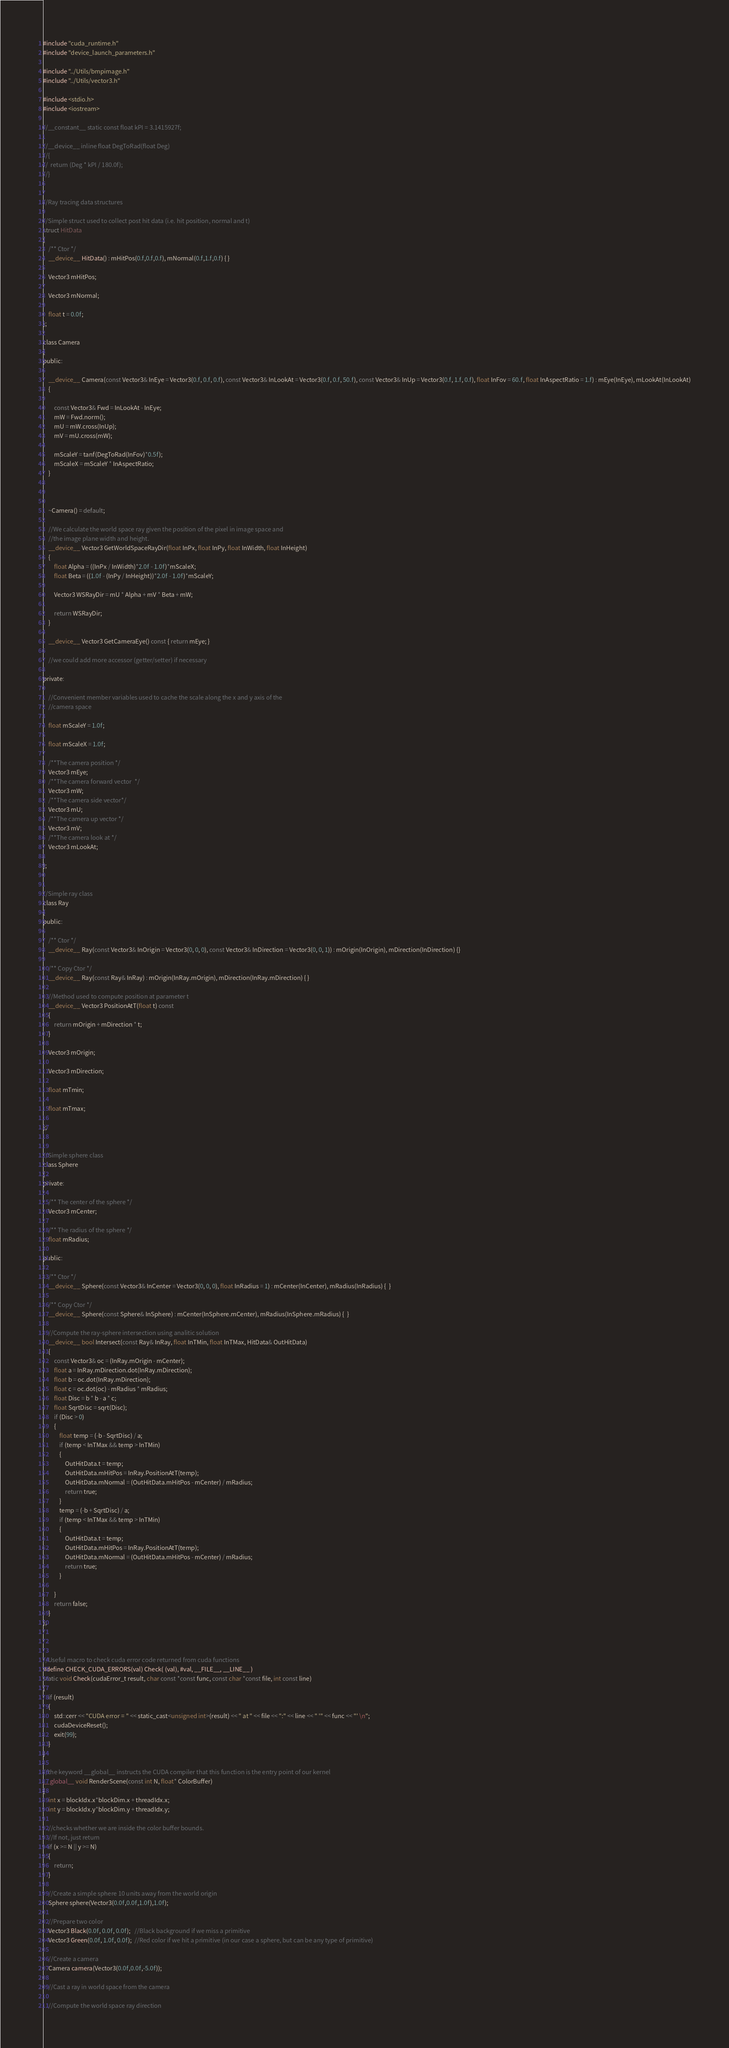<code> <loc_0><loc_0><loc_500><loc_500><_Cuda_>
#include "cuda_runtime.h"
#include "device_launch_parameters.h"

#include "../Utils/bmpimage.h"
#include "../Utils/vector3.h"

#include <stdio.h>
#include <iostream>

//__constant__ static const float kPI = 3.1415927f;

//__device__ inline float DegToRad(float Deg)
//{
//	return (Deg * kPI / 180.0f);
//}


//Ray tracing data structures

//Simple struct used to collect post hit data (i.e. hit position, normal and t)
struct HitData
{
	/** Ctor */
	__device__ HitData() : mHitPos(0.f,0.f,0.f), mNormal(0.f,1.f,0.f) { }
	
	Vector3 mHitPos;
	
	Vector3 mNormal;
	
	float t = 0.0f;
};

class Camera
{
public:

	__device__ Camera(const Vector3& InEye = Vector3(0.f, 0.f, 0.f), const Vector3& InLookAt = Vector3(0.f, 0.f, 50.f), const Vector3& InUp = Vector3(0.f, 1.f, 0.f), float InFov = 60.f, float InAspectRatio = 1.f) : mEye(InEye), mLookAt(InLookAt)
	{

		const Vector3& Fwd = InLookAt - InEye;
		mW = Fwd.norm();
		mU = mW.cross(InUp);
		mV = mU.cross(mW);

		mScaleY = tanf(DegToRad(InFov)*0.5f);
		mScaleX = mScaleY * InAspectRatio;
	}

	

	~Camera() = default;

	//We calculate the world space ray given the position of the pixel in image space and 
	//the image plane width and height.
	__device__ Vector3 GetWorldSpaceRayDir(float InPx, float InPy, float InWidth, float InHeight)
	{
		float Alpha = ((InPx / InWidth)*2.0f - 1.0f)*mScaleX;
		float Beta = ((1.0f - (InPy / InHeight))*2.0f - 1.0f)*mScaleY;

		Vector3 WSRayDir = mU * Alpha + mV * Beta + mW;

		return WSRayDir;
	}

	__device__ Vector3 GetCameraEye() const { return mEye; }

	//we could add more accessor (getter/setter) if necessary

private:

	//Convenient member variables used to cache the scale along the x and y axis of the
	//camera space

	float mScaleY = 1.0f;

	float mScaleX = 1.0f;

	/**The camera position */
	Vector3 mEye;
	/**The camera forward vector  */
	Vector3 mW;
	/**The camera side vector*/
	Vector3 mU;
	/**The camera up vector */
	Vector3 mV;
	/**The camera look at */
	Vector3 mLookAt;

};


//Simple ray class 
class Ray
{
public:
	
	/** Ctor */
	__device__ Ray(const Vector3& InOrigin = Vector3(0, 0, 0), const Vector3& InDirection = Vector3(0, 0, 1)) : mOrigin(InOrigin), mDirection(InDirection) {}

	/** Copy Ctor */
	__device__ Ray(const Ray& InRay) : mOrigin(InRay.mOrigin), mDirection(InRay.mDirection) { }

	//Method used to compute position at parameter t
	__device__ Vector3 PositionAtT(float t) const
	{
		return mOrigin + mDirection * t;
	}

	Vector3 mOrigin;

	Vector3 mDirection;

	float mTmin;

	float mTmax;

};


//Simple sphere class
class Sphere
{
private:

	/** The center of the sphere */
	Vector3 mCenter;

	/** The radius of the sphere */
	float mRadius;

public:

	/** Ctor */
	__device__ Sphere(const Vector3& InCenter = Vector3(0, 0, 0), float InRadius = 1) : mCenter(InCenter), mRadius(InRadius) {  }

	/** Copy Ctor */
	__device__ Sphere(const Sphere& InSphere) : mCenter(InSphere.mCenter), mRadius(InSphere.mRadius) {  }

	//Compute the ray-sphere intersection using analitic solution
	__device__ bool Intersect(const Ray& InRay, float InTMin, float InTMax, HitData& OutHitData)
	{
		const Vector3& oc = (InRay.mOrigin - mCenter);
		float a = InRay.mDirection.dot(InRay.mDirection);
		float b = oc.dot(InRay.mDirection);
		float c = oc.dot(oc) - mRadius * mRadius;
		float Disc = b * b - a * c;
		float SqrtDisc = sqrt(Disc);
		if (Disc > 0)
		{
			float temp = (-b - SqrtDisc) / a;
			if (temp < InTMax && temp > InTMin)
			{
				OutHitData.t = temp;
				OutHitData.mHitPos = InRay.PositionAtT(temp);
				OutHitData.mNormal = (OutHitData.mHitPos - mCenter) / mRadius;
				return true;
			}
			temp = (-b + SqrtDisc) / a;
			if (temp < InTMax && temp > InTMin)
			{
				OutHitData.t = temp;
				OutHitData.mHitPos = InRay.PositionAtT(temp);
				OutHitData.mNormal = (OutHitData.mHitPos - mCenter) / mRadius;
				return true;
			}

		}
		return false;
	}
};



//Useful macro to check cuda error code returned from cuda functions
#define CHECK_CUDA_ERRORS(val) Check( (val), #val, __FILE__, __LINE__ )
static void Check(cudaError_t result, char const *const func, const char *const file, int const line)
{
	if (result)
	{
		std::cerr << "CUDA error = " << static_cast<unsigned int>(result) << " at " << file << ":" << line << " '" << func << "' \n";
		cudaDeviceReset();
		exit(99);
	}
}

//the keyword __global__ instructs the CUDA compiler that this function is the entry point of our kernel
__global__ void RenderScene(const int N, float* ColorBuffer)
{
	int x = blockIdx.x*blockDim.x + threadIdx.x;
	int y = blockIdx.y*blockDim.y + threadIdx.y;

	//checks whether we are inside the color buffer bounds.
	//If not, just return
	if (x >= N || y >= N)
	{
		return;
	}

	//Create a simple sphere 10 units away from the world origin
	Sphere sphere(Vector3(0.0f,0.0f,1.0f),1.0f);

	//Prepare two color
	Vector3 Black(0.0f, 0.0f, 0.0f);   //Black background if we miss a primitive
	Vector3 Green(0.0f, 1.0f, 0.0f);  //Red color if we hit a primitive (in our case a sphere, but can be any type of primitive)

	//Create a camera
	Camera camera(Vector3(0.0f,0.0f,-5.0f));

	//Cast a ray in world space from the camera

	//Compute the world space ray direction</code> 